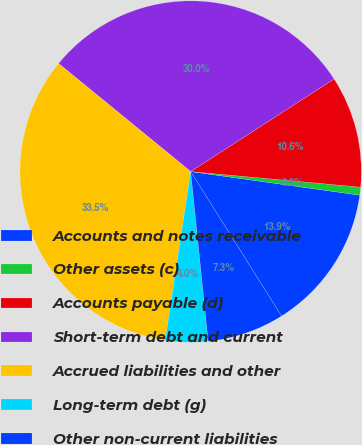<chart> <loc_0><loc_0><loc_500><loc_500><pie_chart><fcel>Accounts and notes receivable<fcel>Other assets (c)<fcel>Accounts payable (d)<fcel>Short-term debt and current<fcel>Accrued liabilities and other<fcel>Long-term debt (g)<fcel>Other non-current liabilities<nl><fcel>13.86%<fcel>0.75%<fcel>10.58%<fcel>29.96%<fcel>33.52%<fcel>4.02%<fcel>7.3%<nl></chart> 